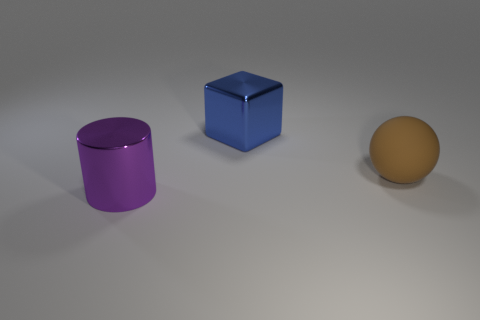Add 3 large gray matte spheres. How many objects exist? 6 Subtract all blocks. How many objects are left? 2 Add 3 small gray rubber things. How many small gray rubber things exist? 3 Subtract 0 green cylinders. How many objects are left? 3 Subtract all big blue objects. Subtract all gray cylinders. How many objects are left? 2 Add 2 balls. How many balls are left? 3 